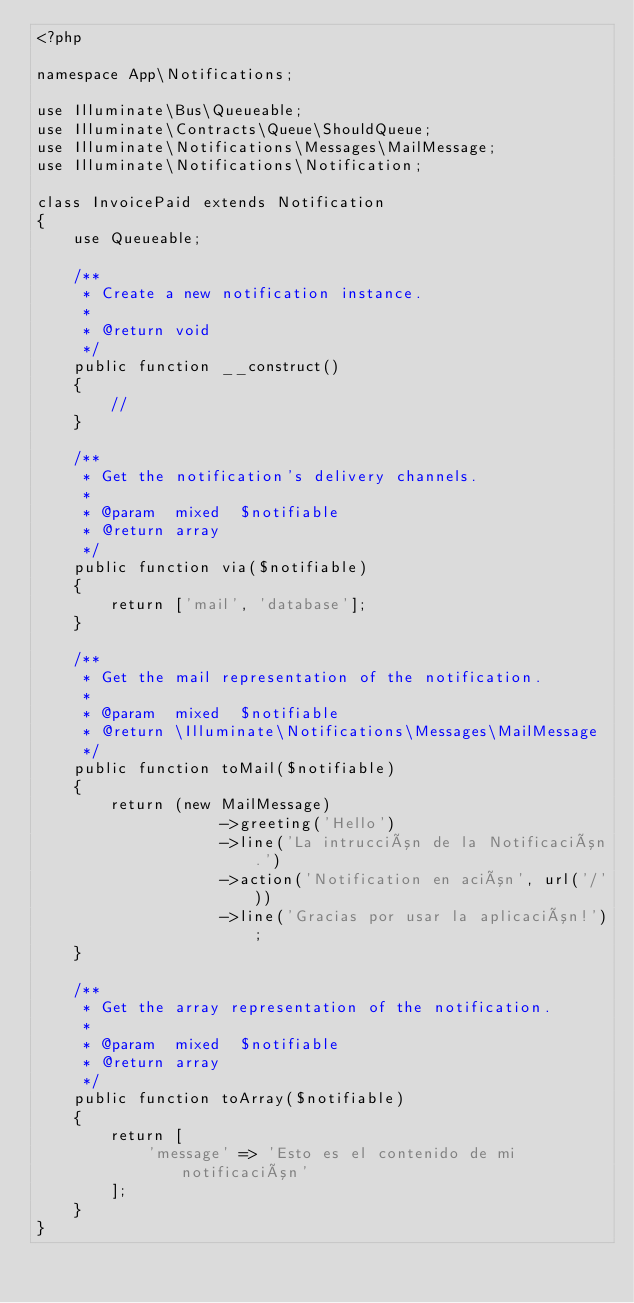<code> <loc_0><loc_0><loc_500><loc_500><_PHP_><?php

namespace App\Notifications;

use Illuminate\Bus\Queueable;
use Illuminate\Contracts\Queue\ShouldQueue;
use Illuminate\Notifications\Messages\MailMessage;
use Illuminate\Notifications\Notification;

class InvoicePaid extends Notification
{
    use Queueable;

    /**
     * Create a new notification instance.
     *
     * @return void
     */
    public function __construct()
    {
        //
    }

    /**
     * Get the notification's delivery channels.
     *
     * @param  mixed  $notifiable
     * @return array
     */
    public function via($notifiable)
    {
        return ['mail', 'database'];
    }

    /**
     * Get the mail representation of the notification.
     *
     * @param  mixed  $notifiable
     * @return \Illuminate\Notifications\Messages\MailMessage
     */
    public function toMail($notifiable)
    {
        return (new MailMessage)
                    ->greeting('Hello')
                    ->line('La intrucción de la Notificación.')
                    ->action('Notification en ación', url('/'))
                    ->line('Gracias por usar la aplicación!');
    }

    /**
     * Get the array representation of the notification.
     *
     * @param  mixed  $notifiable
     * @return array
     */
    public function toArray($notifiable)
    {
        return [
            'message' => 'Esto es el contenido de mi notificación'
        ];
    }
}
</code> 